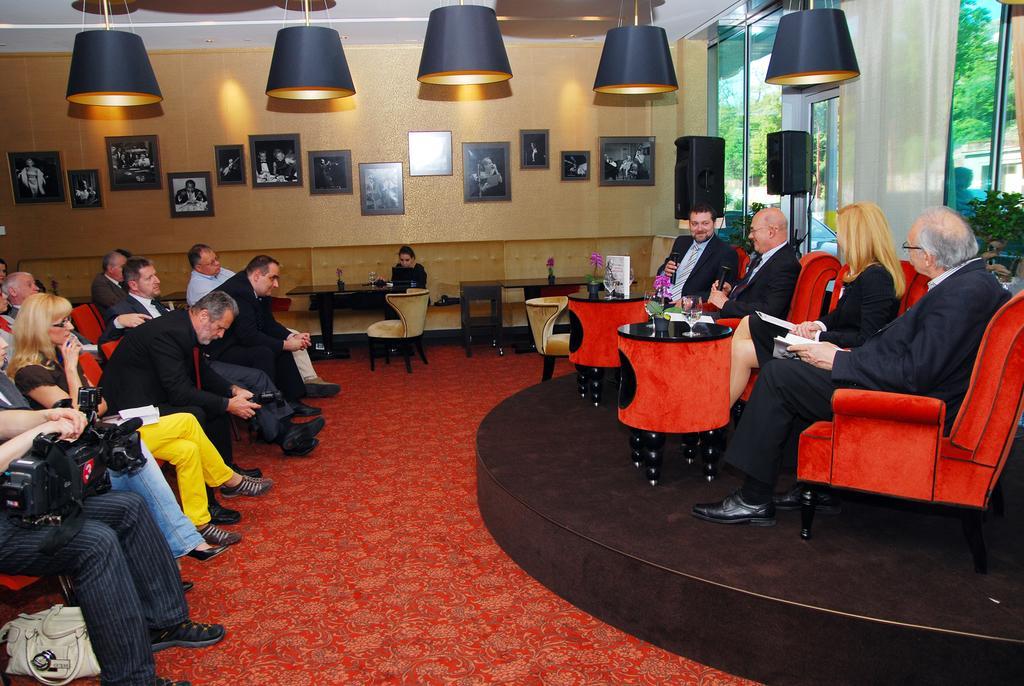How would you summarize this image in a sentence or two? The persons in the left side is sitting in a red chair and there are tables and a group of people sitting in front of them. 